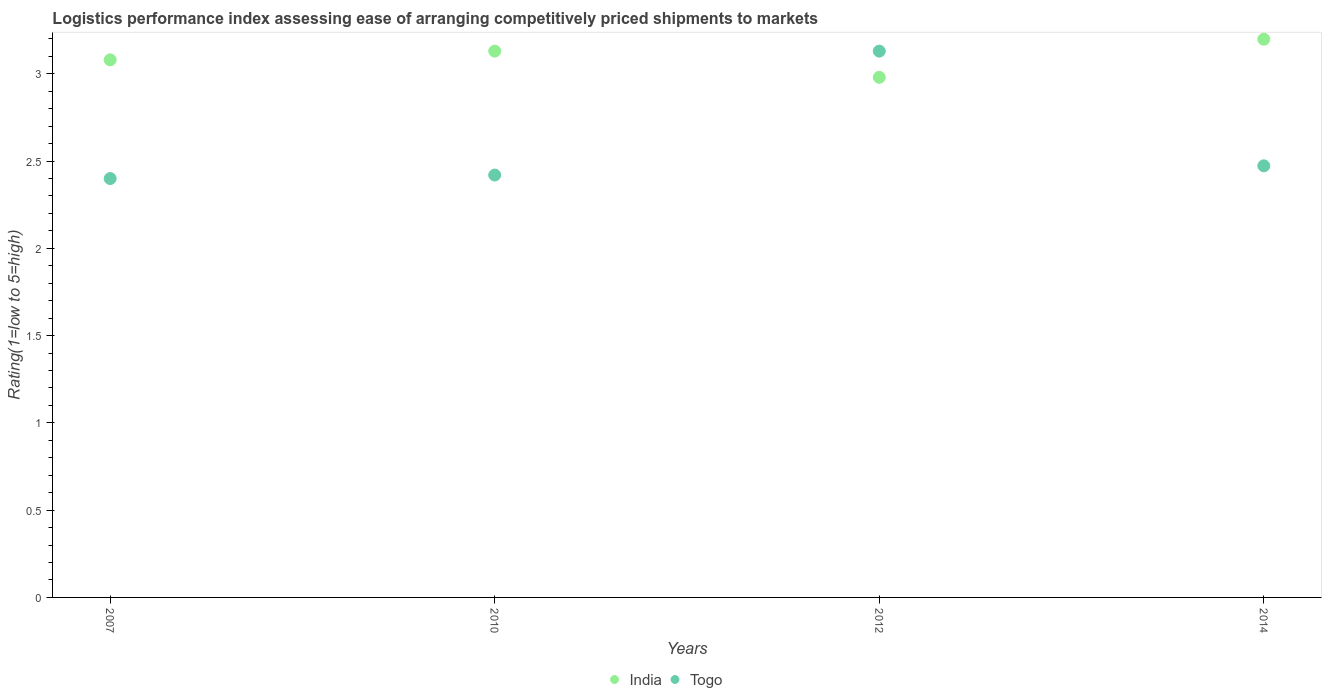How many different coloured dotlines are there?
Your answer should be compact. 2. Is the number of dotlines equal to the number of legend labels?
Keep it short and to the point. Yes. What is the Logistic performance index in India in 2007?
Your response must be concise. 3.08. Across all years, what is the maximum Logistic performance index in Togo?
Keep it short and to the point. 3.13. Across all years, what is the minimum Logistic performance index in Togo?
Your answer should be very brief. 2.4. In which year was the Logistic performance index in India maximum?
Offer a very short reply. 2014. What is the total Logistic performance index in Togo in the graph?
Provide a short and direct response. 10.42. What is the difference between the Logistic performance index in Togo in 2007 and that in 2012?
Keep it short and to the point. -0.73. What is the difference between the Logistic performance index in India in 2014 and the Logistic performance index in Togo in 2007?
Offer a very short reply. 0.8. What is the average Logistic performance index in Togo per year?
Offer a terse response. 2.61. In the year 2014, what is the difference between the Logistic performance index in Togo and Logistic performance index in India?
Your answer should be very brief. -0.73. What is the ratio of the Logistic performance index in India in 2007 to that in 2014?
Offer a very short reply. 0.96. Is the Logistic performance index in India in 2010 less than that in 2012?
Ensure brevity in your answer.  No. What is the difference between the highest and the second highest Logistic performance index in Togo?
Ensure brevity in your answer.  0.66. What is the difference between the highest and the lowest Logistic performance index in India?
Provide a succinct answer. 0.22. Does the Logistic performance index in Togo monotonically increase over the years?
Offer a very short reply. No. How many years are there in the graph?
Your answer should be very brief. 4. Does the graph contain grids?
Offer a very short reply. No. Where does the legend appear in the graph?
Make the answer very short. Bottom center. How many legend labels are there?
Provide a succinct answer. 2. How are the legend labels stacked?
Provide a short and direct response. Horizontal. What is the title of the graph?
Offer a very short reply. Logistics performance index assessing ease of arranging competitively priced shipments to markets. Does "Vanuatu" appear as one of the legend labels in the graph?
Your response must be concise. No. What is the label or title of the Y-axis?
Provide a succinct answer. Rating(1=low to 5=high). What is the Rating(1=low to 5=high) in India in 2007?
Provide a short and direct response. 3.08. What is the Rating(1=low to 5=high) in India in 2010?
Make the answer very short. 3.13. What is the Rating(1=low to 5=high) in Togo in 2010?
Offer a terse response. 2.42. What is the Rating(1=low to 5=high) of India in 2012?
Provide a succinct answer. 2.98. What is the Rating(1=low to 5=high) in Togo in 2012?
Provide a short and direct response. 3.13. What is the Rating(1=low to 5=high) in India in 2014?
Keep it short and to the point. 3.2. What is the Rating(1=low to 5=high) of Togo in 2014?
Offer a very short reply. 2.47. Across all years, what is the maximum Rating(1=low to 5=high) in India?
Your response must be concise. 3.2. Across all years, what is the maximum Rating(1=low to 5=high) in Togo?
Provide a short and direct response. 3.13. Across all years, what is the minimum Rating(1=low to 5=high) in India?
Your response must be concise. 2.98. Across all years, what is the minimum Rating(1=low to 5=high) in Togo?
Offer a terse response. 2.4. What is the total Rating(1=low to 5=high) in India in the graph?
Provide a short and direct response. 12.39. What is the total Rating(1=low to 5=high) in Togo in the graph?
Provide a short and direct response. 10.42. What is the difference between the Rating(1=low to 5=high) in Togo in 2007 and that in 2010?
Keep it short and to the point. -0.02. What is the difference between the Rating(1=low to 5=high) in India in 2007 and that in 2012?
Give a very brief answer. 0.1. What is the difference between the Rating(1=low to 5=high) of Togo in 2007 and that in 2012?
Offer a terse response. -0.73. What is the difference between the Rating(1=low to 5=high) of India in 2007 and that in 2014?
Your answer should be very brief. -0.12. What is the difference between the Rating(1=low to 5=high) in Togo in 2007 and that in 2014?
Offer a very short reply. -0.07. What is the difference between the Rating(1=low to 5=high) of Togo in 2010 and that in 2012?
Your answer should be compact. -0.71. What is the difference between the Rating(1=low to 5=high) in India in 2010 and that in 2014?
Provide a short and direct response. -0.07. What is the difference between the Rating(1=low to 5=high) in Togo in 2010 and that in 2014?
Keep it short and to the point. -0.05. What is the difference between the Rating(1=low to 5=high) of India in 2012 and that in 2014?
Give a very brief answer. -0.22. What is the difference between the Rating(1=low to 5=high) in Togo in 2012 and that in 2014?
Your answer should be very brief. 0.66. What is the difference between the Rating(1=low to 5=high) in India in 2007 and the Rating(1=low to 5=high) in Togo in 2010?
Offer a terse response. 0.66. What is the difference between the Rating(1=low to 5=high) of India in 2007 and the Rating(1=low to 5=high) of Togo in 2012?
Keep it short and to the point. -0.05. What is the difference between the Rating(1=low to 5=high) in India in 2007 and the Rating(1=low to 5=high) in Togo in 2014?
Ensure brevity in your answer.  0.61. What is the difference between the Rating(1=low to 5=high) of India in 2010 and the Rating(1=low to 5=high) of Togo in 2014?
Make the answer very short. 0.66. What is the difference between the Rating(1=low to 5=high) in India in 2012 and the Rating(1=low to 5=high) in Togo in 2014?
Your answer should be very brief. 0.51. What is the average Rating(1=low to 5=high) in India per year?
Provide a succinct answer. 3.1. What is the average Rating(1=low to 5=high) of Togo per year?
Provide a succinct answer. 2.61. In the year 2007, what is the difference between the Rating(1=low to 5=high) in India and Rating(1=low to 5=high) in Togo?
Make the answer very short. 0.68. In the year 2010, what is the difference between the Rating(1=low to 5=high) in India and Rating(1=low to 5=high) in Togo?
Offer a terse response. 0.71. In the year 2012, what is the difference between the Rating(1=low to 5=high) of India and Rating(1=low to 5=high) of Togo?
Provide a short and direct response. -0.15. In the year 2014, what is the difference between the Rating(1=low to 5=high) of India and Rating(1=low to 5=high) of Togo?
Provide a short and direct response. 0.73. What is the ratio of the Rating(1=low to 5=high) in India in 2007 to that in 2010?
Provide a succinct answer. 0.98. What is the ratio of the Rating(1=low to 5=high) in Togo in 2007 to that in 2010?
Ensure brevity in your answer.  0.99. What is the ratio of the Rating(1=low to 5=high) in India in 2007 to that in 2012?
Your answer should be very brief. 1.03. What is the ratio of the Rating(1=low to 5=high) in Togo in 2007 to that in 2012?
Your answer should be compact. 0.77. What is the ratio of the Rating(1=low to 5=high) of Togo in 2007 to that in 2014?
Give a very brief answer. 0.97. What is the ratio of the Rating(1=low to 5=high) in India in 2010 to that in 2012?
Offer a very short reply. 1.05. What is the ratio of the Rating(1=low to 5=high) in Togo in 2010 to that in 2012?
Give a very brief answer. 0.77. What is the ratio of the Rating(1=low to 5=high) in India in 2010 to that in 2014?
Give a very brief answer. 0.98. What is the ratio of the Rating(1=low to 5=high) of Togo in 2010 to that in 2014?
Your response must be concise. 0.98. What is the ratio of the Rating(1=low to 5=high) of India in 2012 to that in 2014?
Provide a succinct answer. 0.93. What is the ratio of the Rating(1=low to 5=high) in Togo in 2012 to that in 2014?
Your response must be concise. 1.27. What is the difference between the highest and the second highest Rating(1=low to 5=high) of India?
Offer a very short reply. 0.07. What is the difference between the highest and the second highest Rating(1=low to 5=high) of Togo?
Keep it short and to the point. 0.66. What is the difference between the highest and the lowest Rating(1=low to 5=high) in India?
Your answer should be compact. 0.22. What is the difference between the highest and the lowest Rating(1=low to 5=high) of Togo?
Your answer should be very brief. 0.73. 